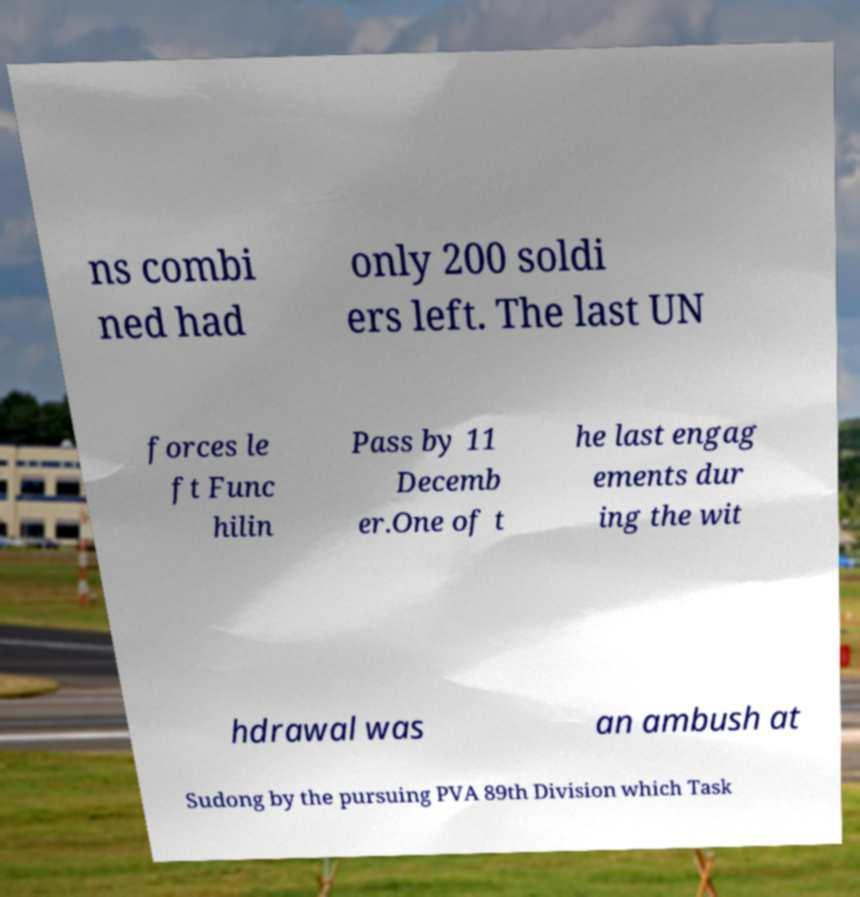I need the written content from this picture converted into text. Can you do that? ns combi ned had only 200 soldi ers left. The last UN forces le ft Func hilin Pass by 11 Decemb er.One of t he last engag ements dur ing the wit hdrawal was an ambush at Sudong by the pursuing PVA 89th Division which Task 